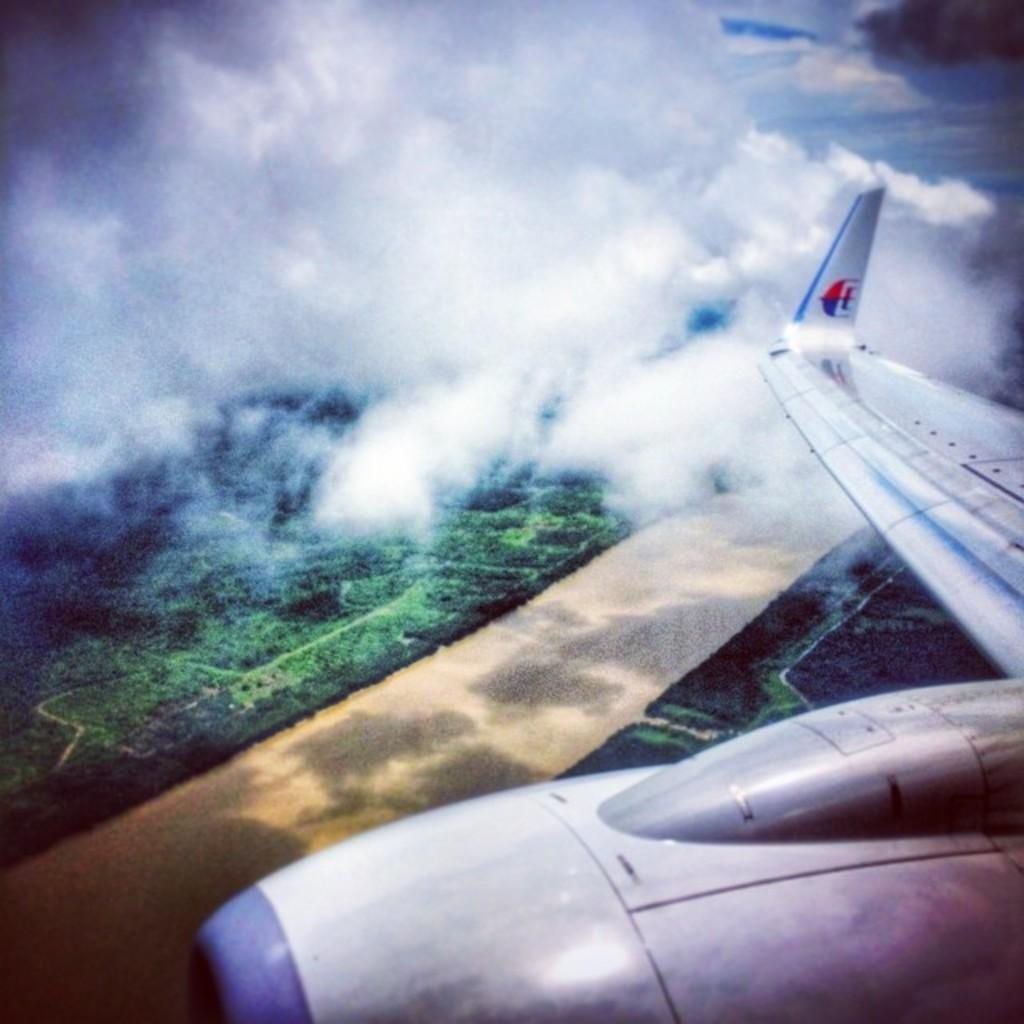What is the main subject of the image? The main subject of the image is an aircraft. Where is the aircraft located in the image? The aircraft is on the right side of the image. What is the condition of the sky in the image? The sky is cloudy in the image. How is the cloudy sky positioned in the image? The cloudy sky is at the top and left most of the image. What type of terrain is visible in the image? There is a grassy land in the image. Can you see a boy eating soup in the image? There is no boy eating soup present in the image. What type of soup is being served in the image? There is no soup present in the image. 